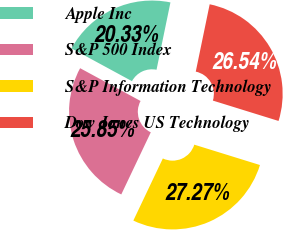Convert chart to OTSL. <chart><loc_0><loc_0><loc_500><loc_500><pie_chart><fcel>Apple Inc<fcel>S&P 500 Index<fcel>S&P Information Technology<fcel>Dow Jones US Technology<nl><fcel>20.33%<fcel>25.85%<fcel>27.27%<fcel>26.54%<nl></chart> 